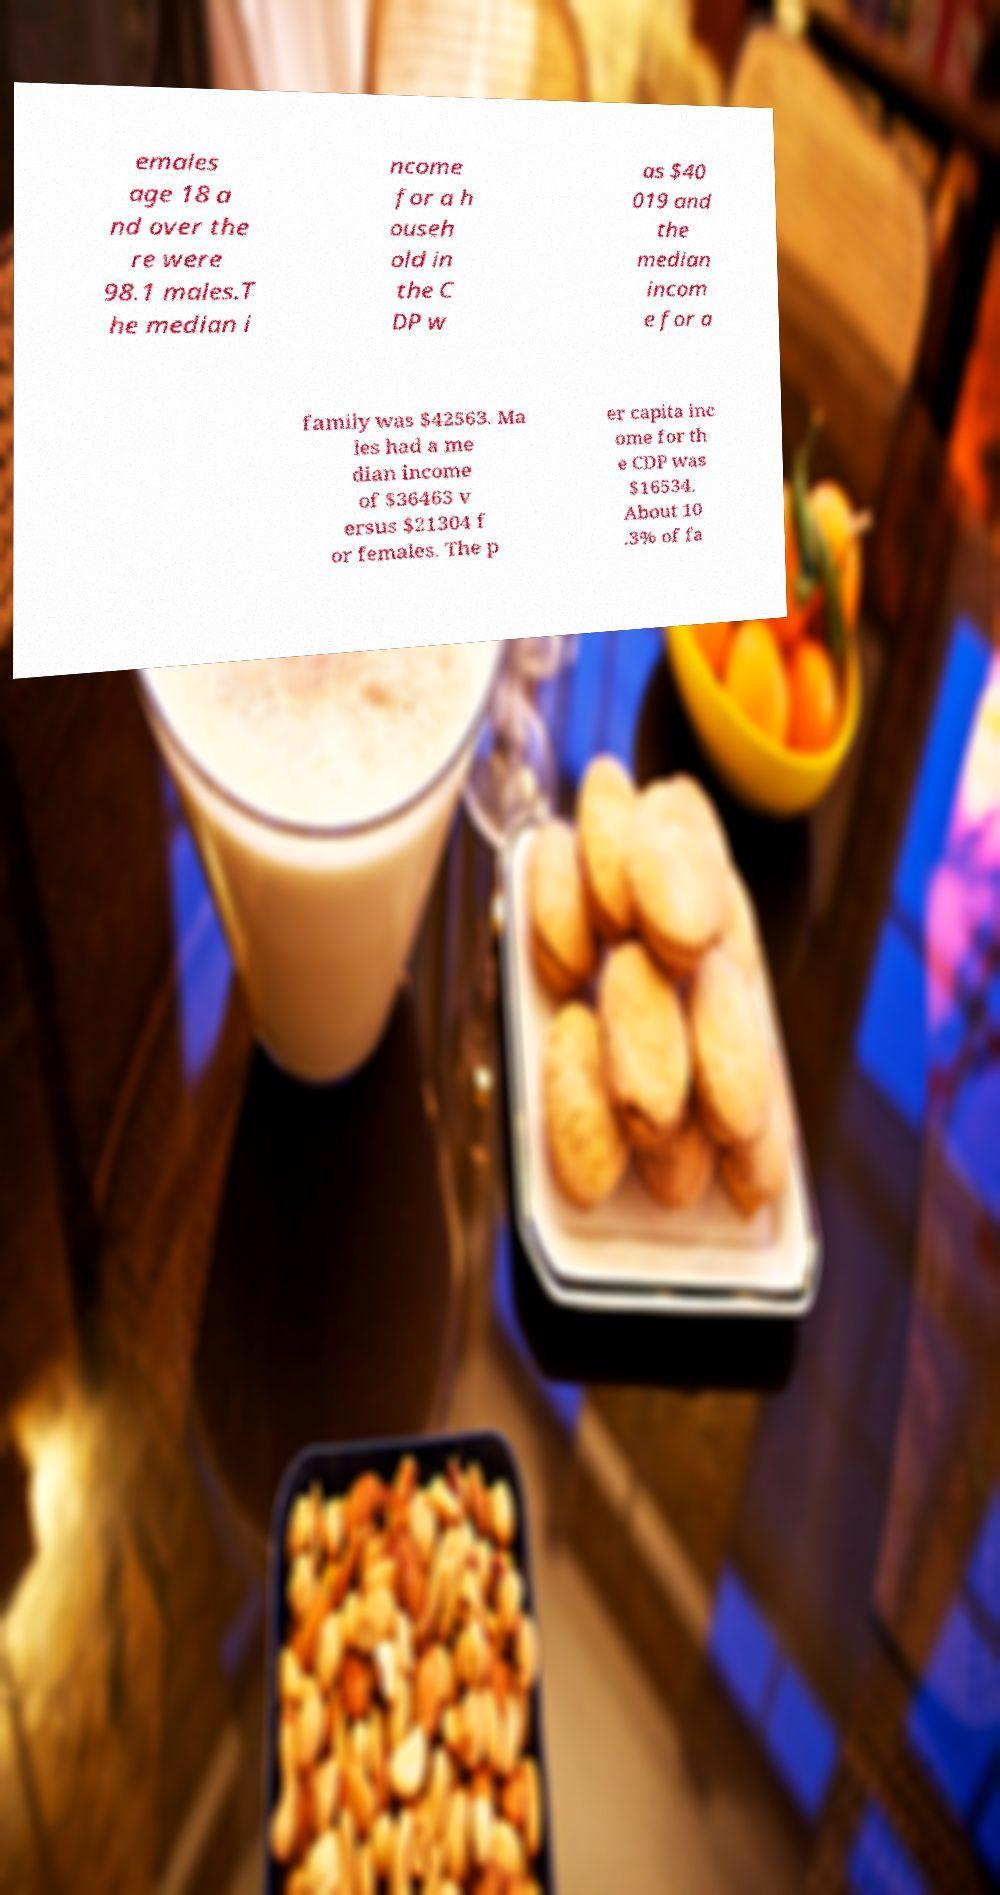Can you accurately transcribe the text from the provided image for me? emales age 18 a nd over the re were 98.1 males.T he median i ncome for a h ouseh old in the C DP w as $40 019 and the median incom e for a family was $42563. Ma les had a me dian income of $36463 v ersus $21304 f or females. The p er capita inc ome for th e CDP was $16534. About 10 .3% of fa 